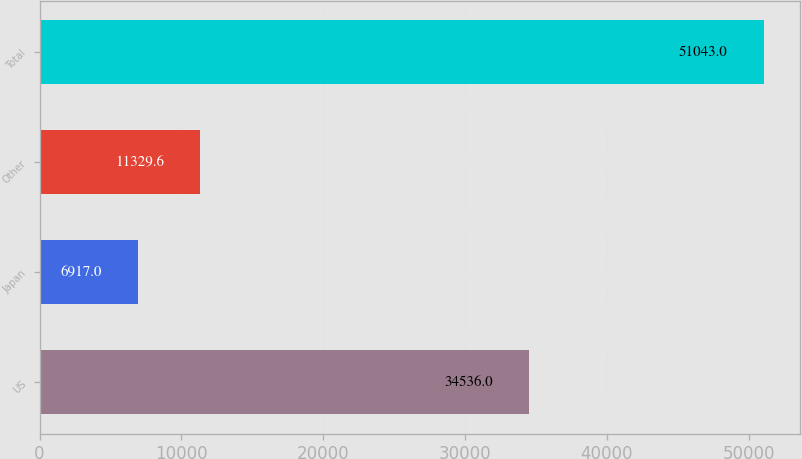Convert chart. <chart><loc_0><loc_0><loc_500><loc_500><bar_chart><fcel>US<fcel>Japan<fcel>Other<fcel>Total<nl><fcel>34536<fcel>6917<fcel>11329.6<fcel>51043<nl></chart> 